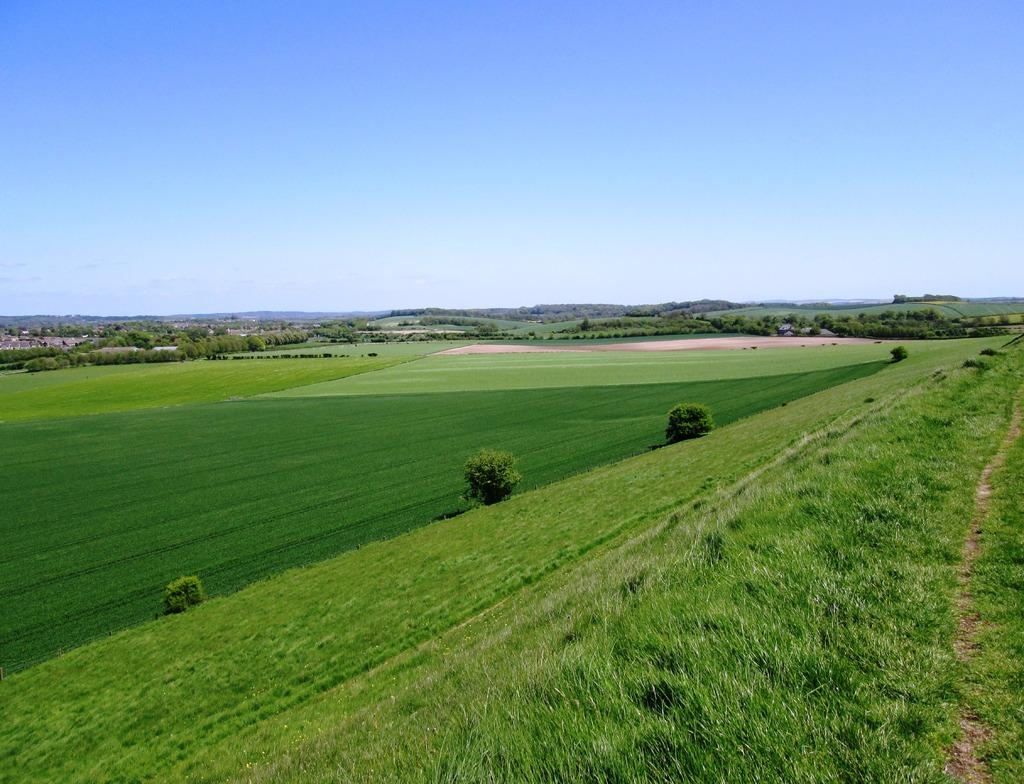Where was the image taken? The image was taken outdoors. What can be seen at the top of the image? The sky is visible at the top of the image. What is visible at the bottom of the image? The ground is visible at the bottom of the image. What type of vegetation is present on the ground? There is grass, plants, and trees on the ground. How many gold pies are visible in the image? There are no gold pies present in the image. Can you see any goldfish swimming in the grass? There are no goldfish present in the image, and goldfish typically do not swim in grass. 